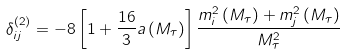<formula> <loc_0><loc_0><loc_500><loc_500>\delta ^ { ( 2 ) } _ { i j } = - 8 \left [ 1 + \frac { 1 6 } { 3 } a \left ( M _ { \tau } \right ) \right ] \frac { m ^ { 2 } _ { i } \left ( M _ { \tau } \right ) + m ^ { 2 } _ { j } \left ( M _ { \tau } \right ) } { M _ { \tau } ^ { 2 } }</formula> 